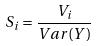Convert formula to latex. <formula><loc_0><loc_0><loc_500><loc_500>S _ { i } = \frac { V _ { i } } { V a r ( Y ) }</formula> 